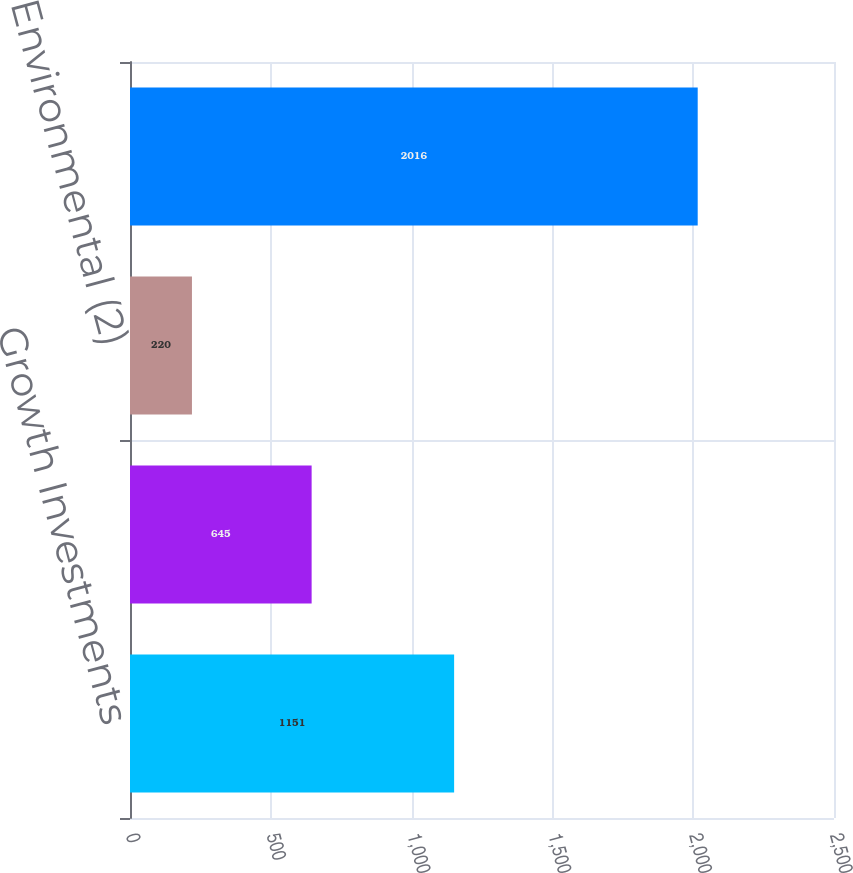<chart> <loc_0><loc_0><loc_500><loc_500><bar_chart><fcel>Growth Investments<fcel>Maintenance<fcel>Environmental (2)<fcel>Total capital expenditures<nl><fcel>1151<fcel>645<fcel>220<fcel>2016<nl></chart> 